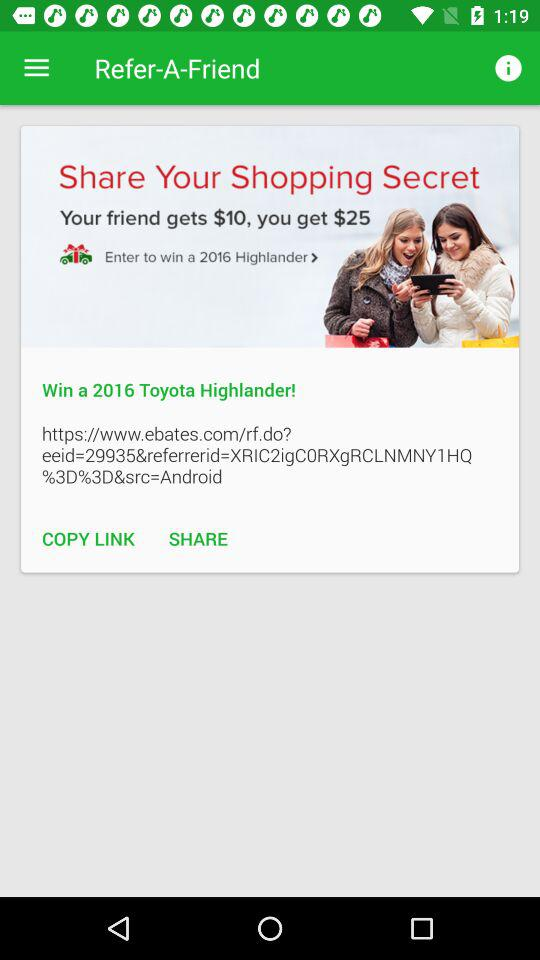How many more dollars does the user get than their friend?
Answer the question using a single word or phrase. 15 